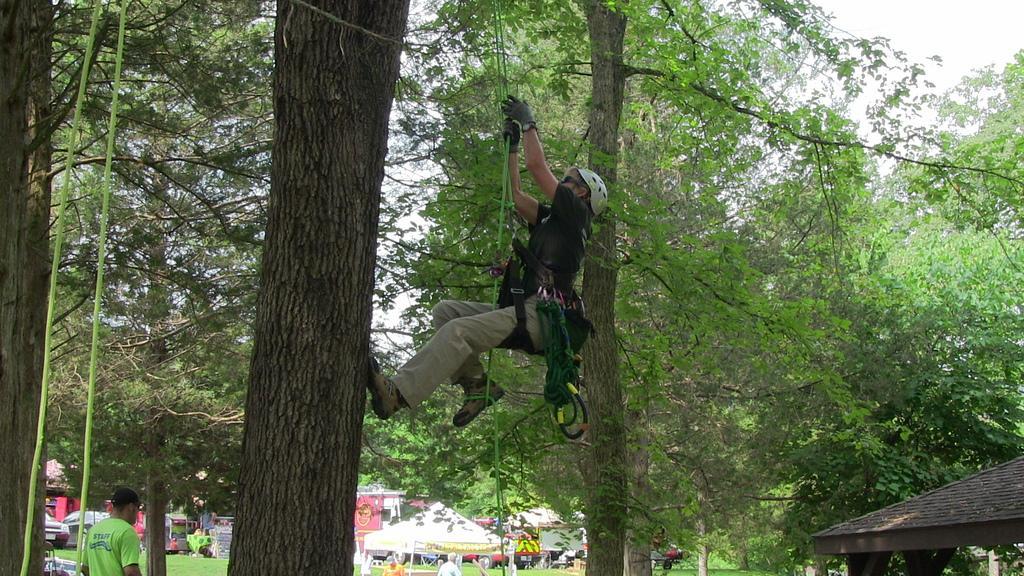Could you give a brief overview of what you see in this image? In this picture I can observe a man in the middle of the picture, climbing a tree, holding a rope in his hands. In the bottom of the picture I can observe white color tint. In the background there are some trees and sky. 